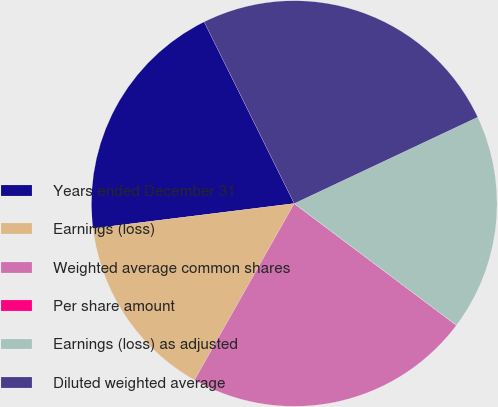Convert chart. <chart><loc_0><loc_0><loc_500><loc_500><pie_chart><fcel>Years ended December 31<fcel>Earnings (loss)<fcel>Weighted average common shares<fcel>Per share amount<fcel>Earnings (loss) as adjusted<fcel>Diluted weighted average<nl><fcel>19.64%<fcel>14.85%<fcel>22.93%<fcel>0.01%<fcel>17.25%<fcel>25.32%<nl></chart> 